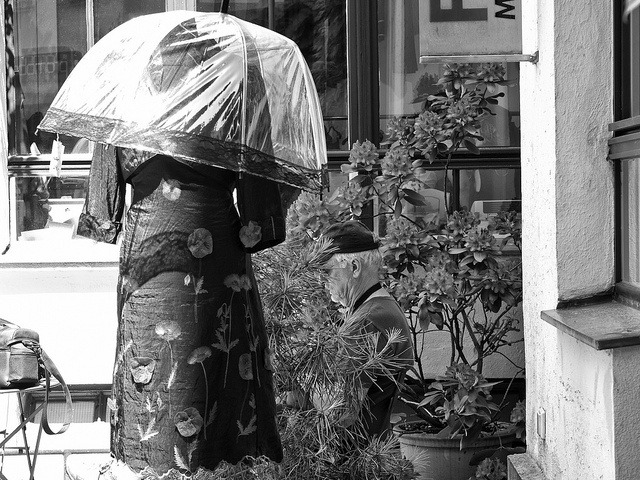Describe the objects in this image and their specific colors. I can see people in darkgray, black, gray, and lightgray tones, potted plant in darkgray, black, gray, and lightgray tones, umbrella in darkgray, white, gray, and black tones, people in darkgray, black, gray, and lightgray tones, and handbag in darkgray, lightgray, gray, and black tones in this image. 